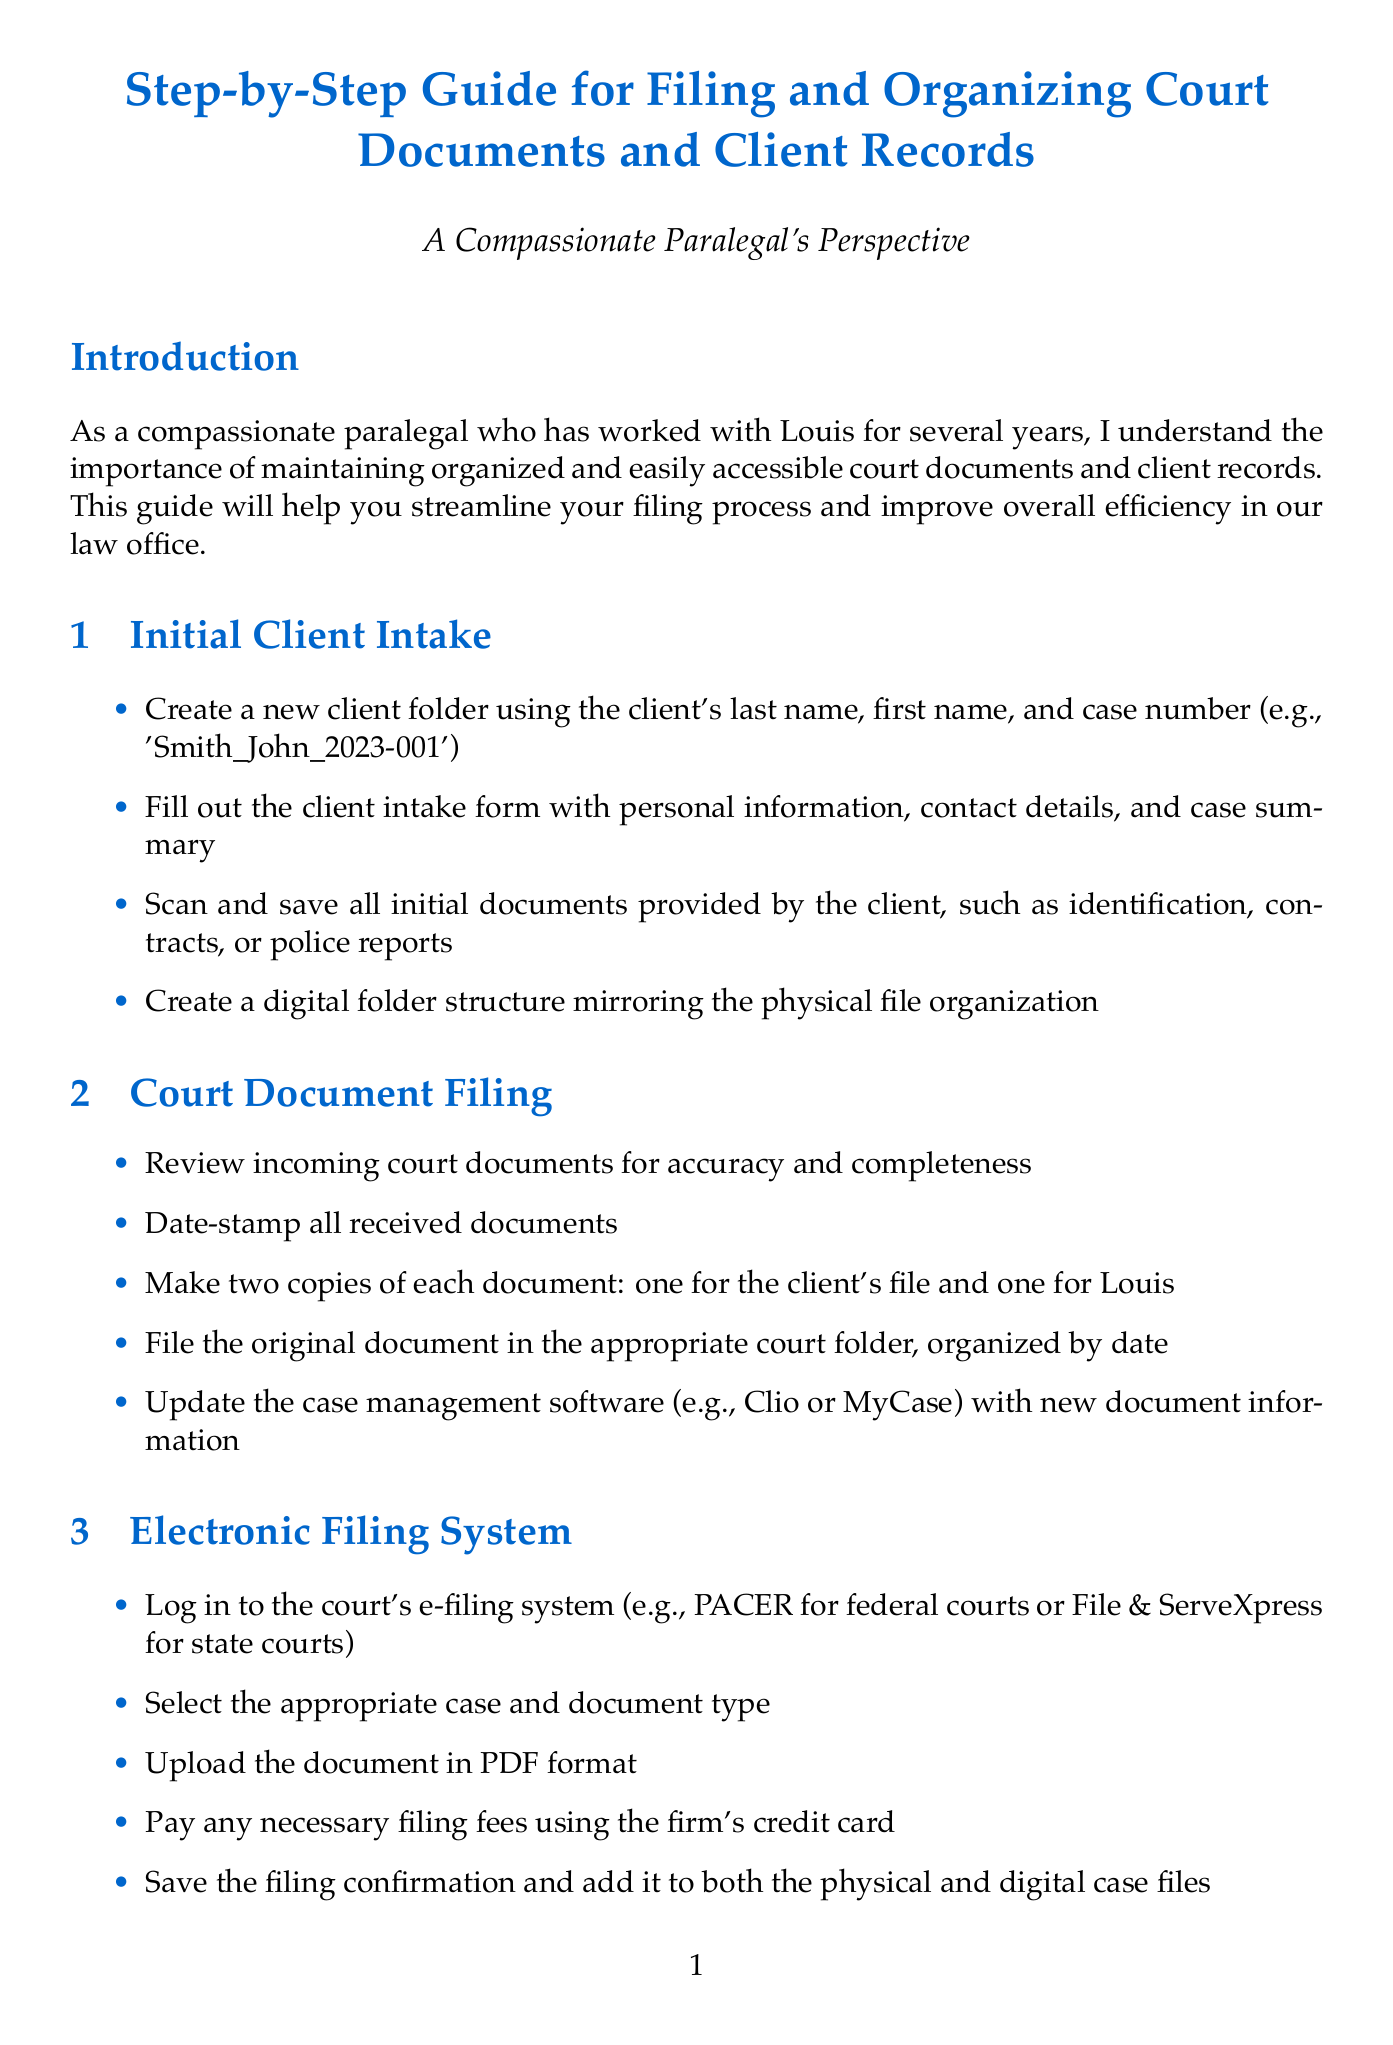What is the title of the guide? The title is presented at the beginning of the document, which is about filing and organizing court documents and client records.
Answer: Step-by-Step Guide for Filing and Organizing Court Documents and Client Records How many sections are there in the document? The document lists six main sections that provide different aspects of filing and organizing procedures.
Answer: Six What should be included in the initial client intake form? The steps in the initial client intake section mention that personal information, contact details, and case summary should be filled out.
Answer: Personal information, contact details, and case summary What color tabs should be used to distinguish documents? The organization section mentions using colored tabs or folders, so we can infer the color is not specified but must be colored.
Answer: Colored What is the purpose of storing physical files in locked cabinets? The purpose relates to confidentiality and secure information management as stated in the confidentiality section.
Answer: Confidentiality What periodic action should be taken to maintain organized files? The document states that conducting monthly audits is a regular action recommended for keeping files in order.
Answer: Monthly audits What should be done with discarded documents containing client information? It is stated in the confidentiality section that such documents should be shredded to ensure security.
Answer: Shredded What document management software is mentioned for updates? The guide specifies that Clio or MyCase should be used for updating document information.
Answer: Clio or MyCase Who does the conclusion emphasize relies on organizational skills? The conclusion mentions that Louis relies on the organizational skills to support his legal work effectively.
Answer: Louis 